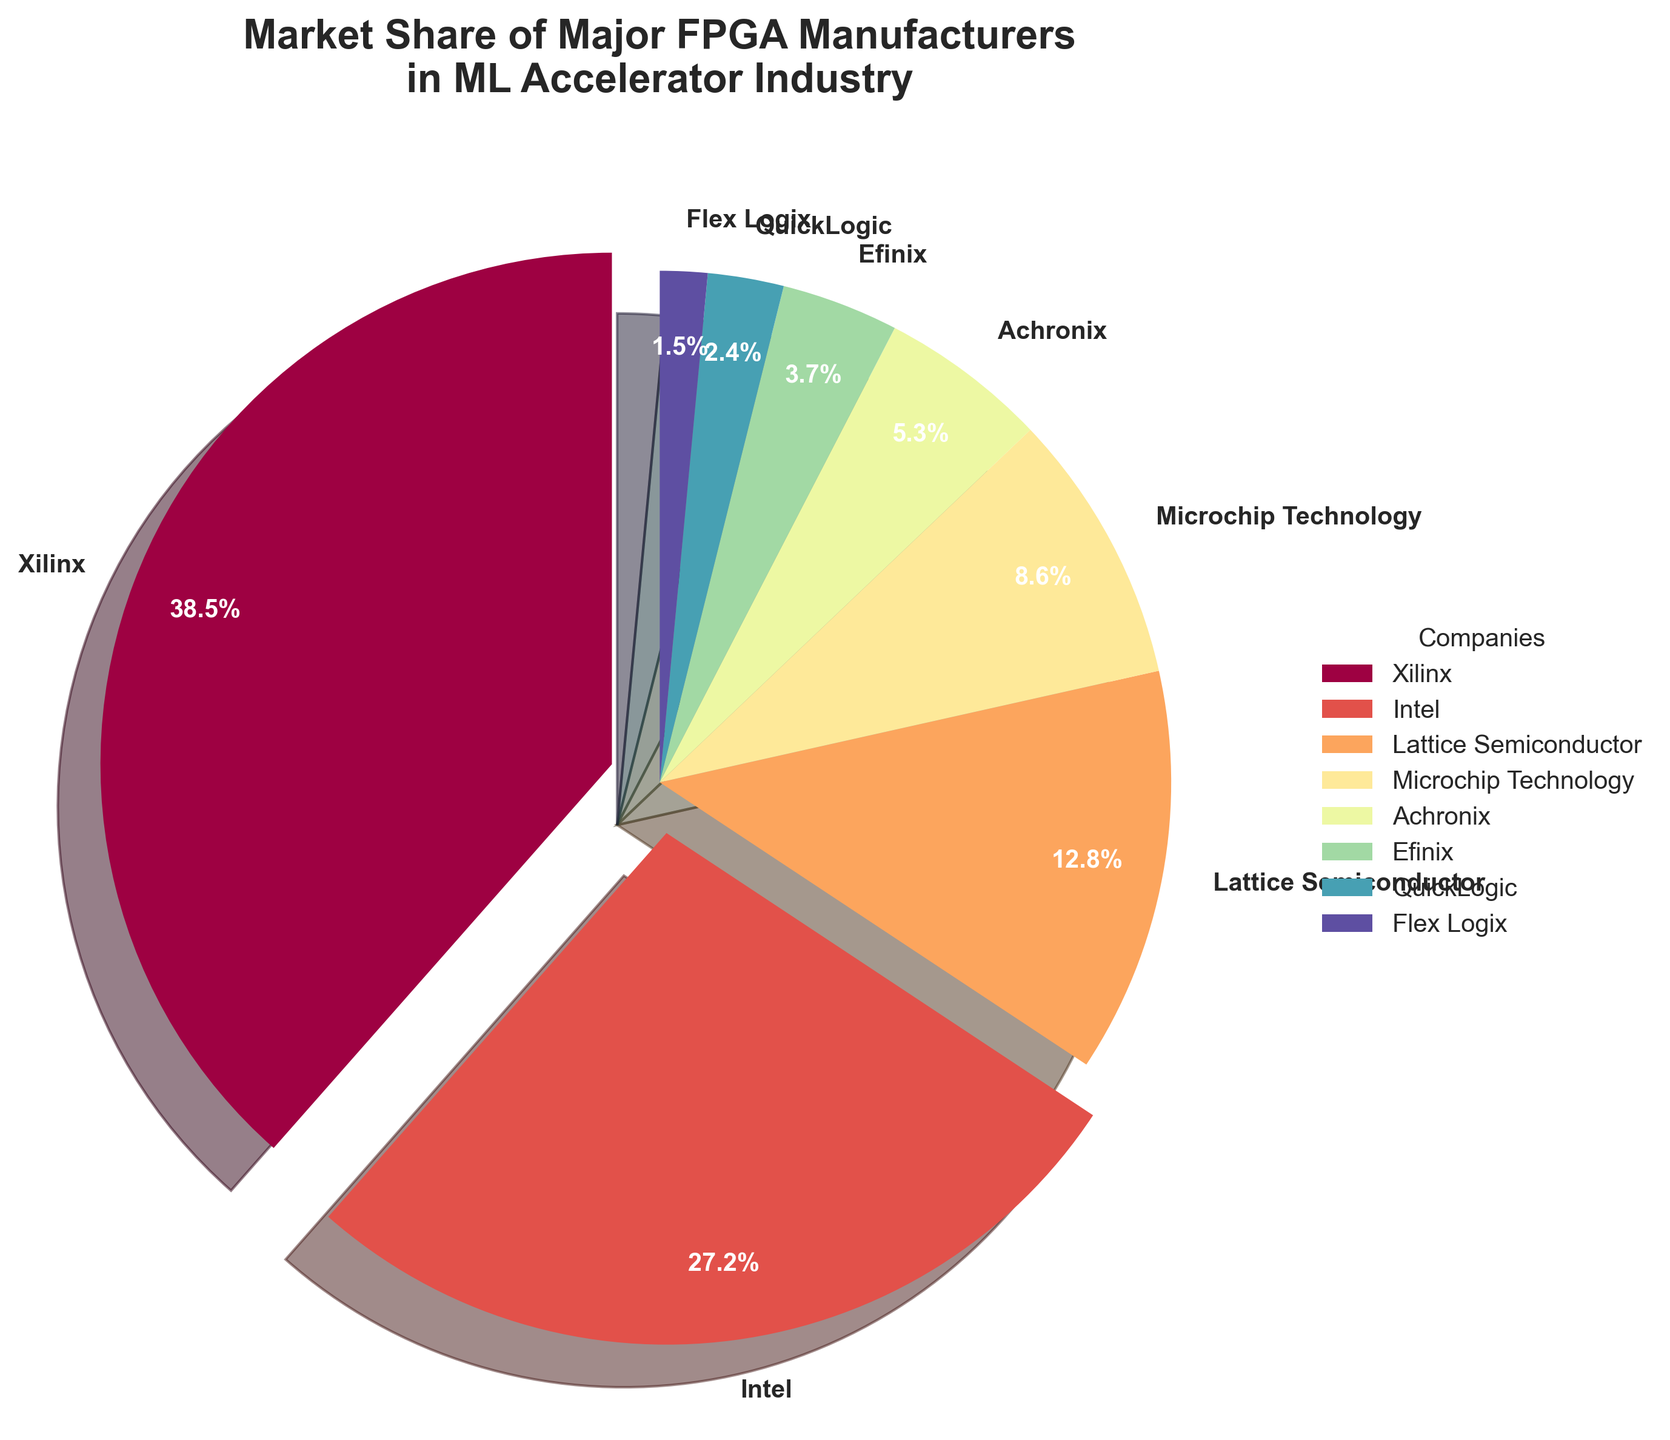What's the combined market share of Xilinx and Intel? Xilinx has a market share of 38.5% and Intel has a market share of 27.2%. Adding these together gives 38.5 + 27.2 = 65.7%.
Answer: 65.7% Which company has the smallest market share? Flex Logix has the smallest slice in the pie chart among all companies listed.
Answer: Flex Logix By how much does Lattice Semiconductor's market share exceed Efinix's? Lattice Semiconductor has a market share of 12.8%, and Efinix has a market share of 3.7%. Subtracting the two gives 12.8 - 3.7 = 9.1%.
Answer: 9.1% What is the difference in market share between the largest and smallest companies? The largest market share is Xilinx with 38.5% and the smallest is Flex Logix with 1.5%. The difference is 38.5 - 1.5 = 37%.
Answer: 37% Which two companies have a combined market share approximately equal to Microchip Technology's? Efinix has a 3.7% share and QuickLogic has a 2.4% share. Together, their combined share is 3.7 + 2.4 = 6.1%, which is closest to Microchip Technology's 8.6%, though not exact.
Answer: Efinix and QuickLogic Based on visual clues, which company has the most prominent slice excluding labels with a 0.1 explode? Xilinx's slice is exploded and is more prominent, indicating it has a significant share. The next largest, visually not exploded, is Intel.
Answer: Intel What is the sum of the market shares of the companies that have a market share below 10%? Companies below 10% are Lattice Semiconductor (12.8%), Microchip Technology (8.6%), Achronix (5.3%), Efinix (3.7%), QuickLogic (2.4%), Flex Logix (1.5%). The sum is 12.8 + 8.6 + 5.3 + 3.7 + 2.4 + 1.5 = 34.3%.
Answer: 34.3% What is the median market share of the companies listed? The market shares in ascending order are: 1.5, 2.4, 3.7, 5.3, 8.6, 12.8, 27.2, 38.5. The middle values are 5.3 and 8.6, and the median is (5.3 + 8.6) / 2 = 6.95.
Answer: 6.95 What color is the slice representing Microchip Technology? In the pie chart, the colors change smoothly with distinct segments. Microchip Technology is somewhere in the middle range, visually represented by a distinct color, which may be a shade between green and yellow visually.
Answer: Light Green/Yellow Which company has the third largest market share? Xilinx and Intel have the largest shares. The third largest share is held by Lattice Semiconductor with 12.8%.
Answer: Lattice Semiconductor 